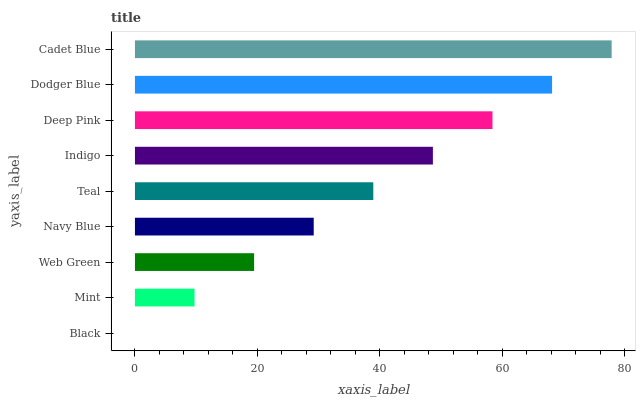Is Black the minimum?
Answer yes or no. Yes. Is Cadet Blue the maximum?
Answer yes or no. Yes. Is Mint the minimum?
Answer yes or no. No. Is Mint the maximum?
Answer yes or no. No. Is Mint greater than Black?
Answer yes or no. Yes. Is Black less than Mint?
Answer yes or no. Yes. Is Black greater than Mint?
Answer yes or no. No. Is Mint less than Black?
Answer yes or no. No. Is Teal the high median?
Answer yes or no. Yes. Is Teal the low median?
Answer yes or no. Yes. Is Dodger Blue the high median?
Answer yes or no. No. Is Web Green the low median?
Answer yes or no. No. 